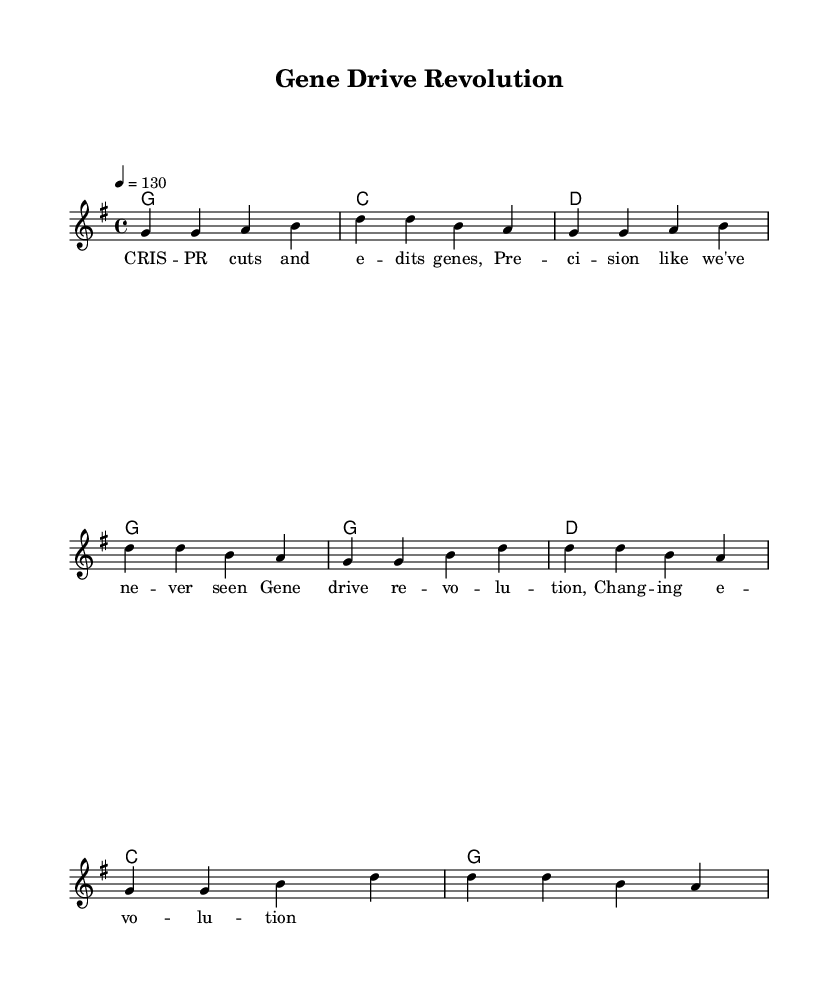What is the key signature of this music? The music is in G major, which has one sharp (F#) in its key signature. This can be determined by looking for the key signature symbol at the beginning of the staff.
Answer: G major What is the time signature of this piece? The time signature is denoted at the beginning of the score, showing a 4 over 4, which indicates there are four beats in each measure.
Answer: 4/4 What is the tempo marking of this music? The tempo is indicated with a quarter note equaling 130 beats per minute, which signifies a moderately fast pace for the track.
Answer: 130 How many measures are in the verse? By counting the distinct groups of notes and rests, we see there are 4 measures in the verse section of the song.
Answer: 4 What is the pattern of harmonic progression in the chorus? Analyzing the chords, the progression follows a pattern of G, D, C, G, suggesting a common progression for country rock songs that emphasizes the tonic, dominant, and subdominant chords.
Answer: G, D, C, G Why is the title significant in the context of the lyrics? The title "Gene Drive Revolution" connects directly to the themes in the lyrics, focusing on cutting-edge genetic engineering technology that can alter evolution, thus reflecting a celebration of technological advancements in biological research.
Answer: Gene Drive Revolution 